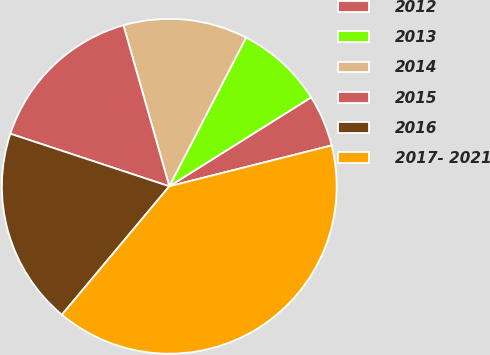<chart> <loc_0><loc_0><loc_500><loc_500><pie_chart><fcel>2012<fcel>2013<fcel>2014<fcel>2015<fcel>2016<fcel>2017- 2021<nl><fcel>4.99%<fcel>8.5%<fcel>12.0%<fcel>15.5%<fcel>19.0%<fcel>40.01%<nl></chart> 